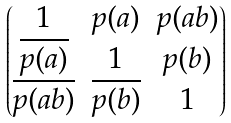Convert formula to latex. <formula><loc_0><loc_0><loc_500><loc_500>\begin{pmatrix} 1 & p ( a ) & p ( a b ) \\ \overline { p ( a ) } & 1 & p ( b ) \\ \overline { p ( a b ) } & \overline { p ( b ) } & 1 \\ \end{pmatrix}</formula> 